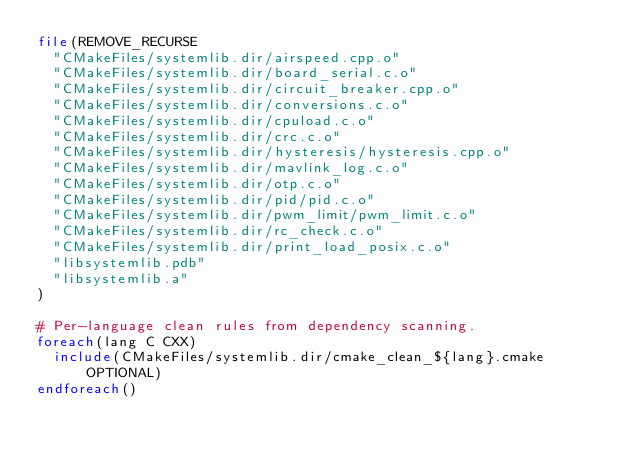Convert code to text. <code><loc_0><loc_0><loc_500><loc_500><_CMake_>file(REMOVE_RECURSE
  "CMakeFiles/systemlib.dir/airspeed.cpp.o"
  "CMakeFiles/systemlib.dir/board_serial.c.o"
  "CMakeFiles/systemlib.dir/circuit_breaker.cpp.o"
  "CMakeFiles/systemlib.dir/conversions.c.o"
  "CMakeFiles/systemlib.dir/cpuload.c.o"
  "CMakeFiles/systemlib.dir/crc.c.o"
  "CMakeFiles/systemlib.dir/hysteresis/hysteresis.cpp.o"
  "CMakeFiles/systemlib.dir/mavlink_log.c.o"
  "CMakeFiles/systemlib.dir/otp.c.o"
  "CMakeFiles/systemlib.dir/pid/pid.c.o"
  "CMakeFiles/systemlib.dir/pwm_limit/pwm_limit.c.o"
  "CMakeFiles/systemlib.dir/rc_check.c.o"
  "CMakeFiles/systemlib.dir/print_load_posix.c.o"
  "libsystemlib.pdb"
  "libsystemlib.a"
)

# Per-language clean rules from dependency scanning.
foreach(lang C CXX)
  include(CMakeFiles/systemlib.dir/cmake_clean_${lang}.cmake OPTIONAL)
endforeach()
</code> 